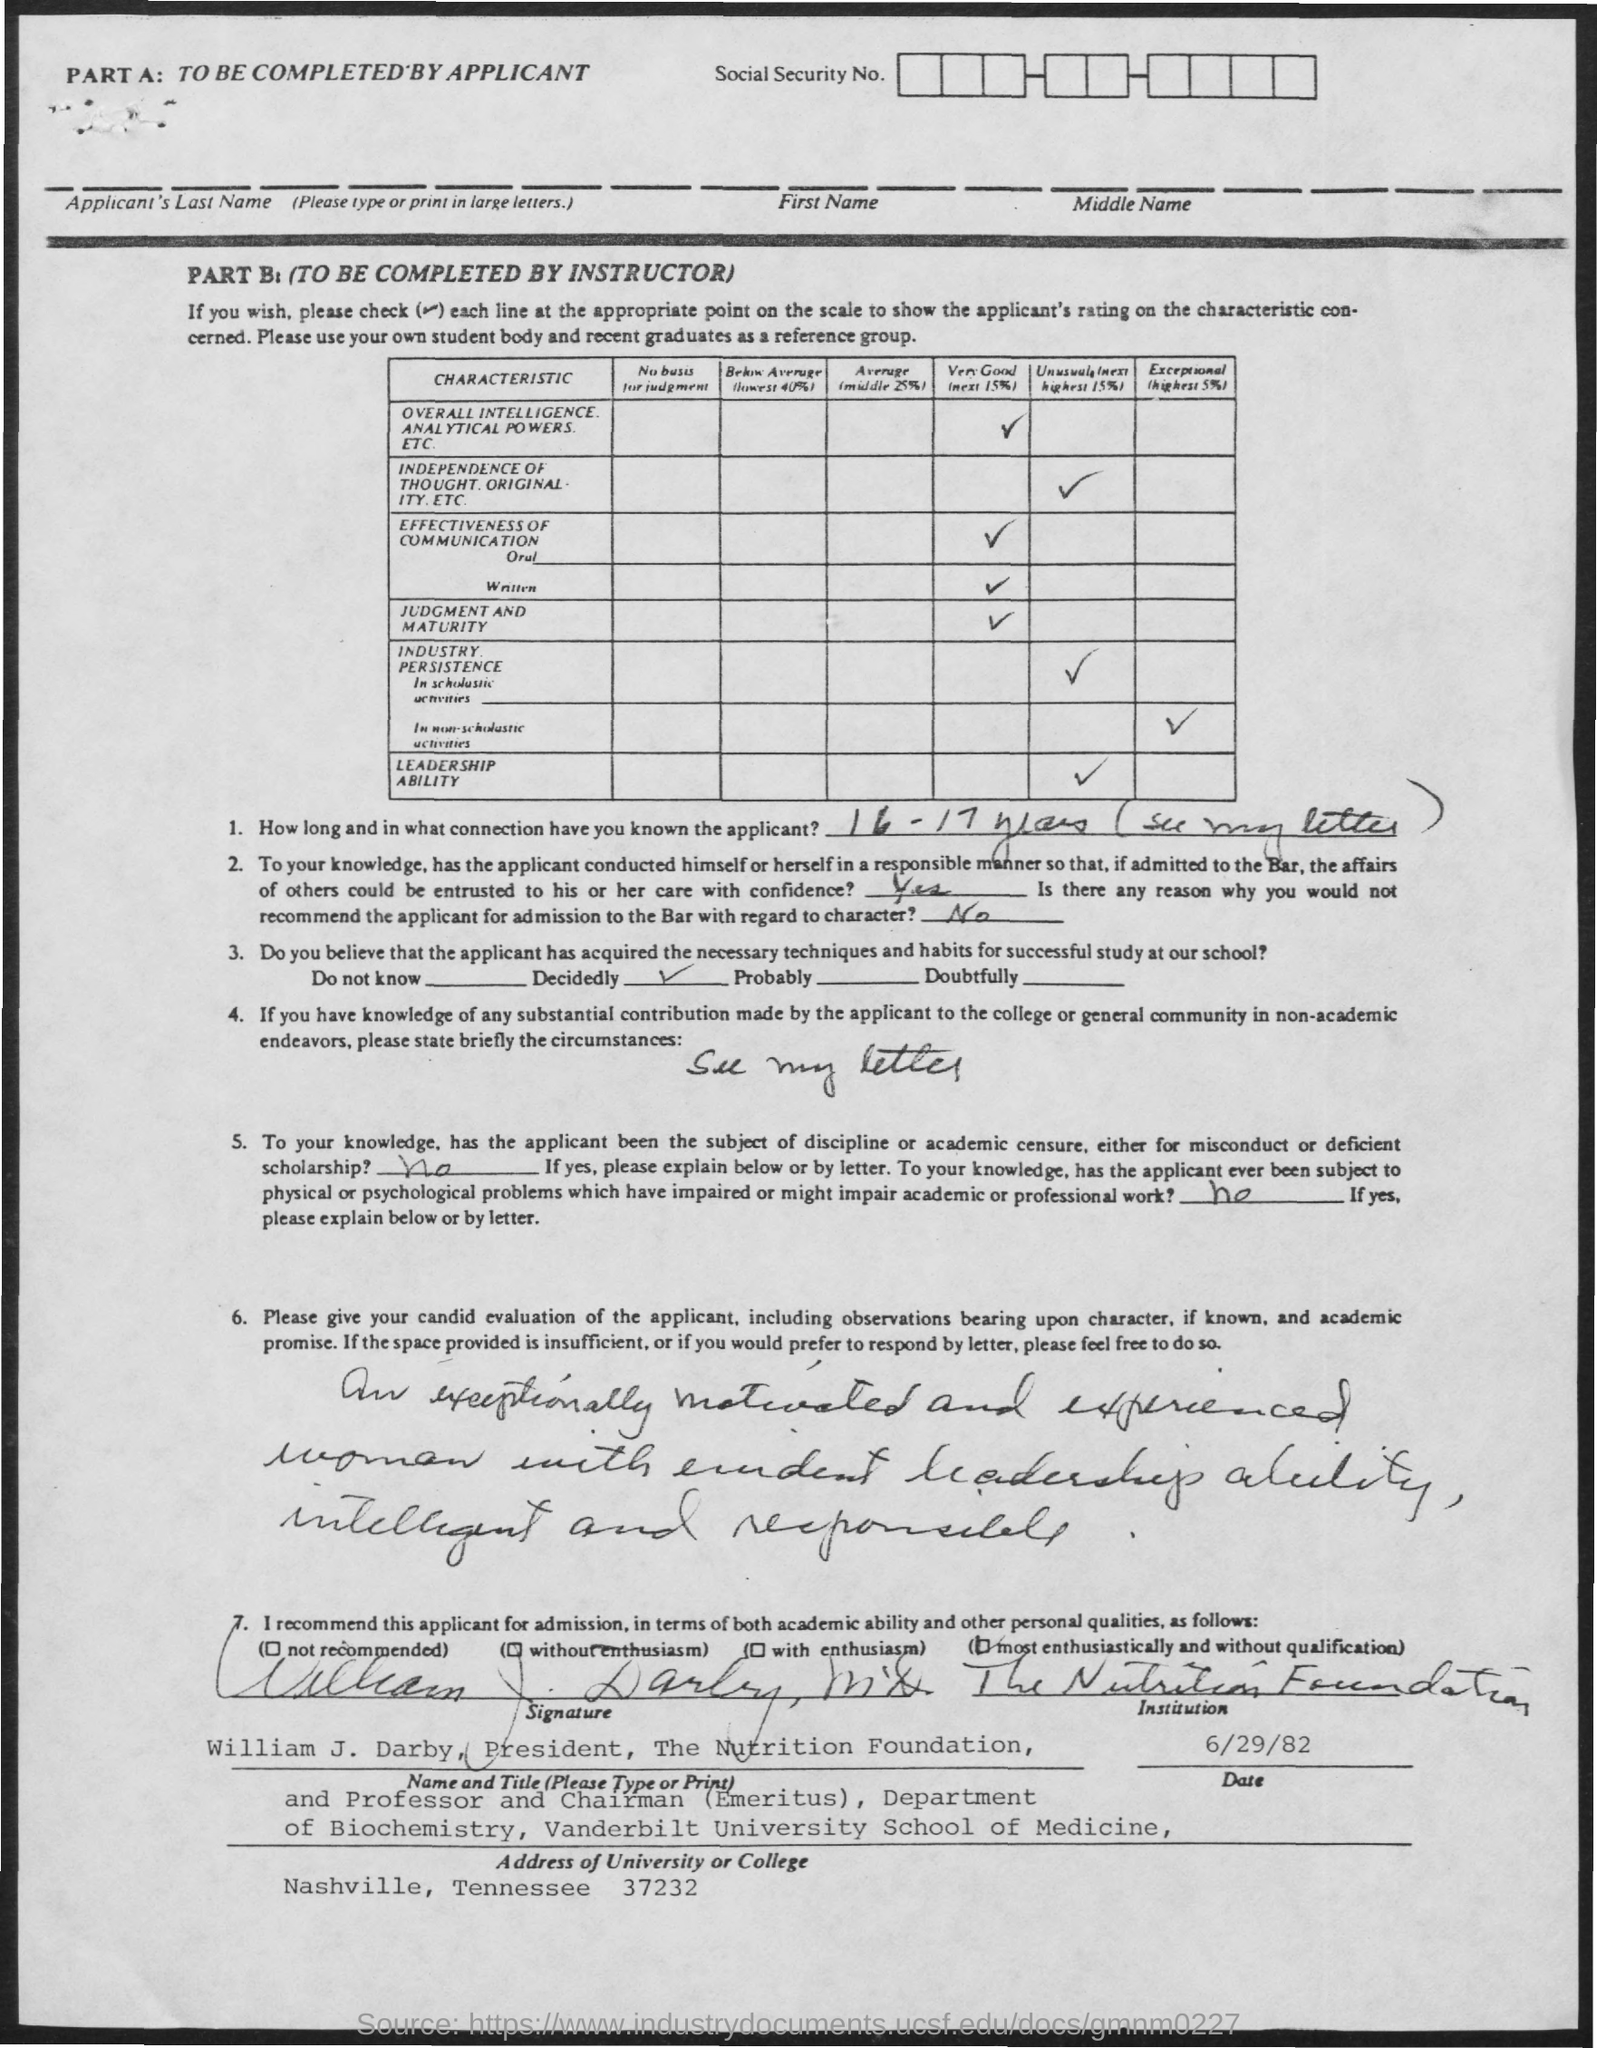What is the date mentioned in the given page ?
Ensure brevity in your answer.  6/29/82. What is the address of university or college mentioned ?
Provide a short and direct response. Nashville, tennessee 37232. Who's sign was there at the bottom of the letter ?
Your answer should be very brief. William j. darby. 